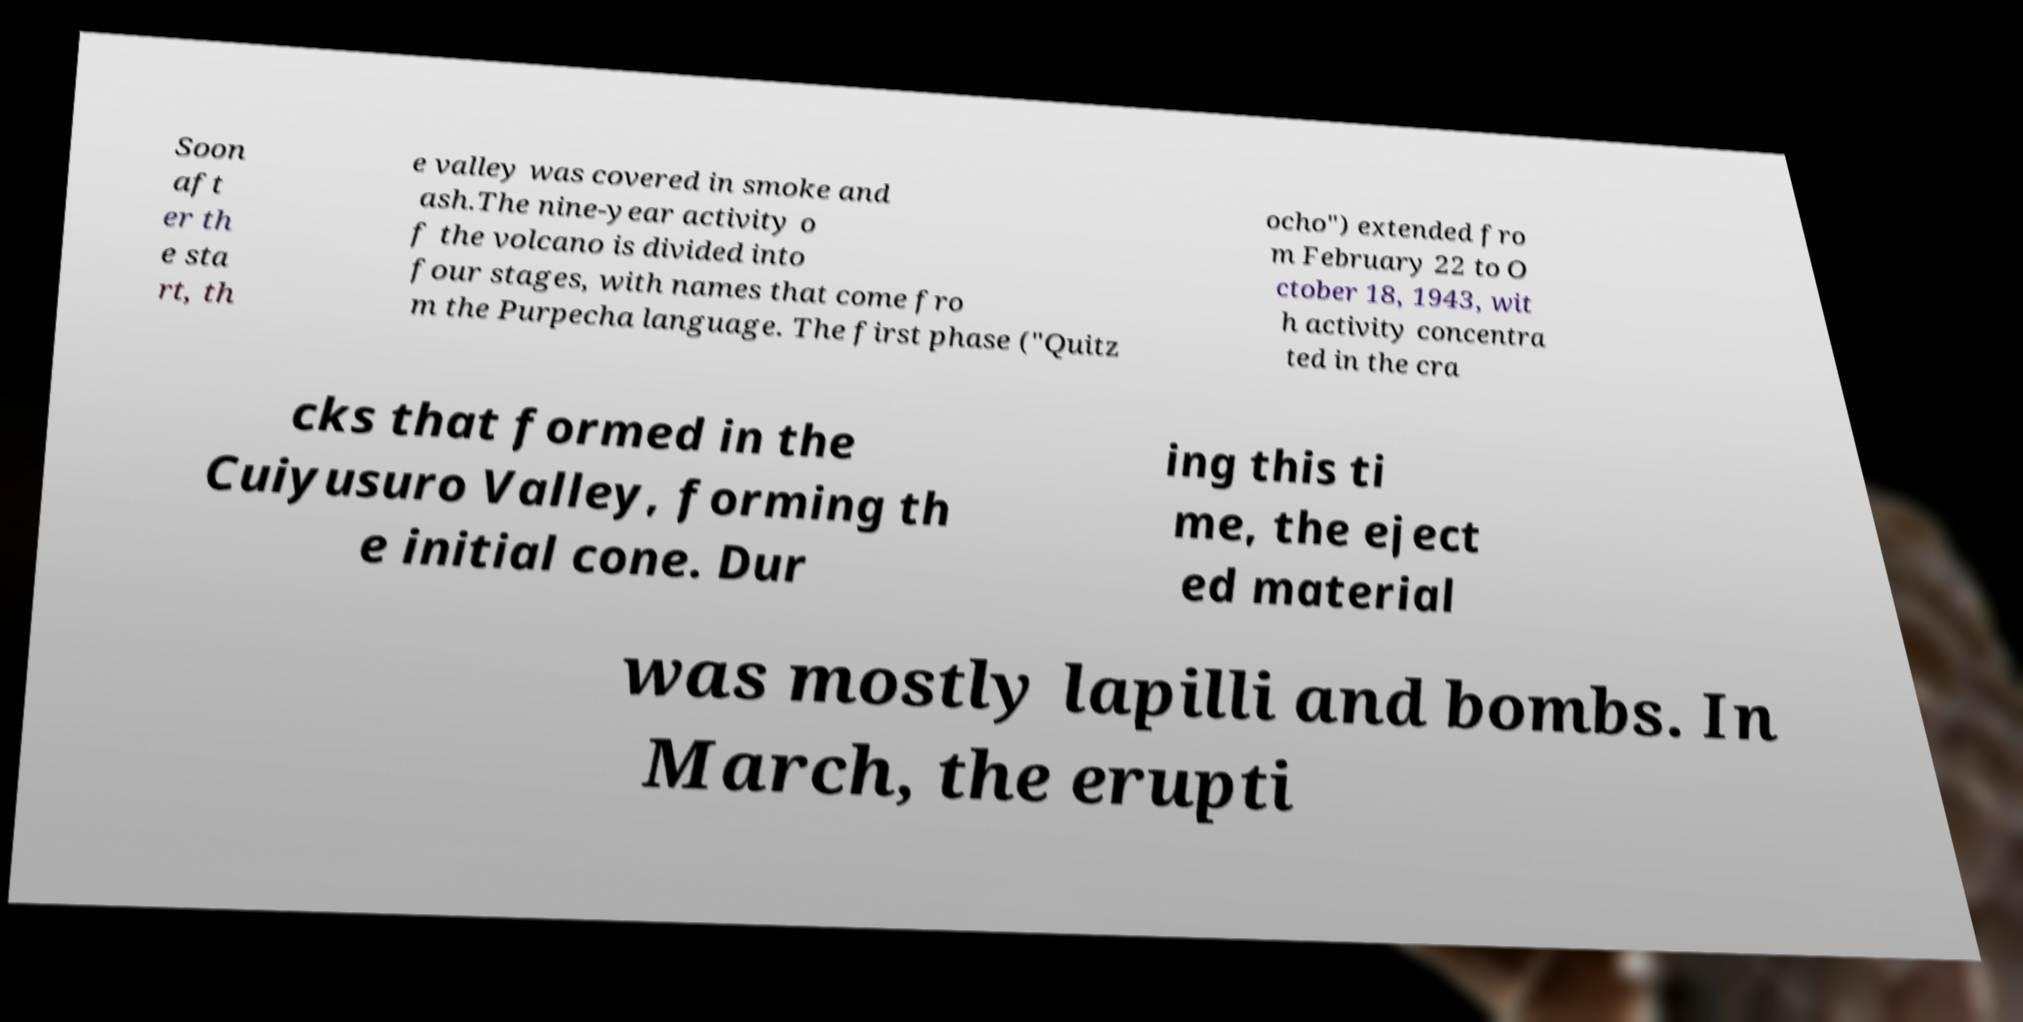Please read and relay the text visible in this image. What does it say? Soon aft er th e sta rt, th e valley was covered in smoke and ash.The nine-year activity o f the volcano is divided into four stages, with names that come fro m the Purpecha language. The first phase ("Quitz ocho") extended fro m February 22 to O ctober 18, 1943, wit h activity concentra ted in the cra cks that formed in the Cuiyusuro Valley, forming th e initial cone. Dur ing this ti me, the eject ed material was mostly lapilli and bombs. In March, the erupti 